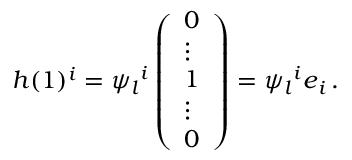<formula> <loc_0><loc_0><loc_500><loc_500>h ( 1 ) ^ { i } = { \psi _ { l } } ^ { i } \left ( \begin{array} { l } { 0 } \\ { \vdots } \\ { 1 } \\ { \vdots } \\ { 0 } \end{array} \right ) = { \psi _ { l } } ^ { i } e _ { i } \, .</formula> 